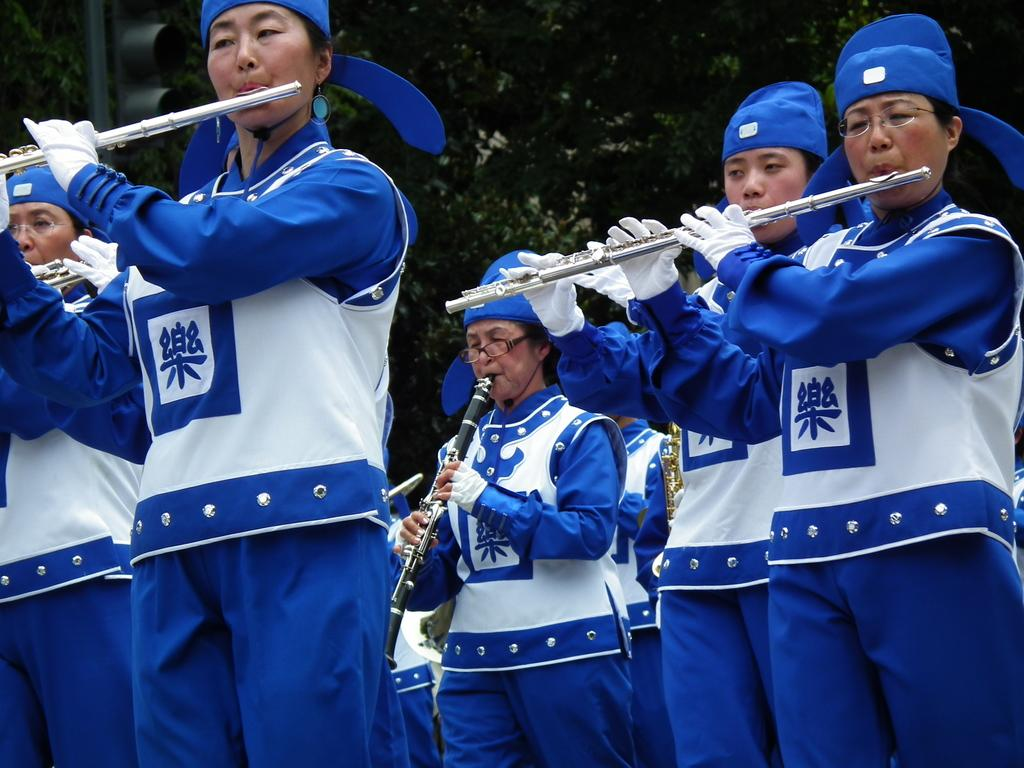What are the people in the image doing? The people in the image are standing and holding music instruments. What can be seen in the background of the image? There are green color trees in the background of the image. What type of sugar can be smelled in the image? There is no mention of sugar or any scent in the image, so it cannot be determined from the image. 